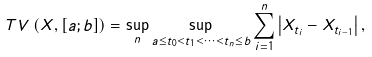Convert formula to latex. <formula><loc_0><loc_0><loc_500><loc_500>T V \left ( X , \left [ a ; b \right ] \right ) = \sup _ { n } \sup _ { a \leq t _ { 0 } < t _ { 1 } < \dots < t _ { n } \leq b } \sum _ { i = 1 } ^ { n } \left | X _ { t _ { i } } - X _ { t _ { i - 1 } } \right | ,</formula> 